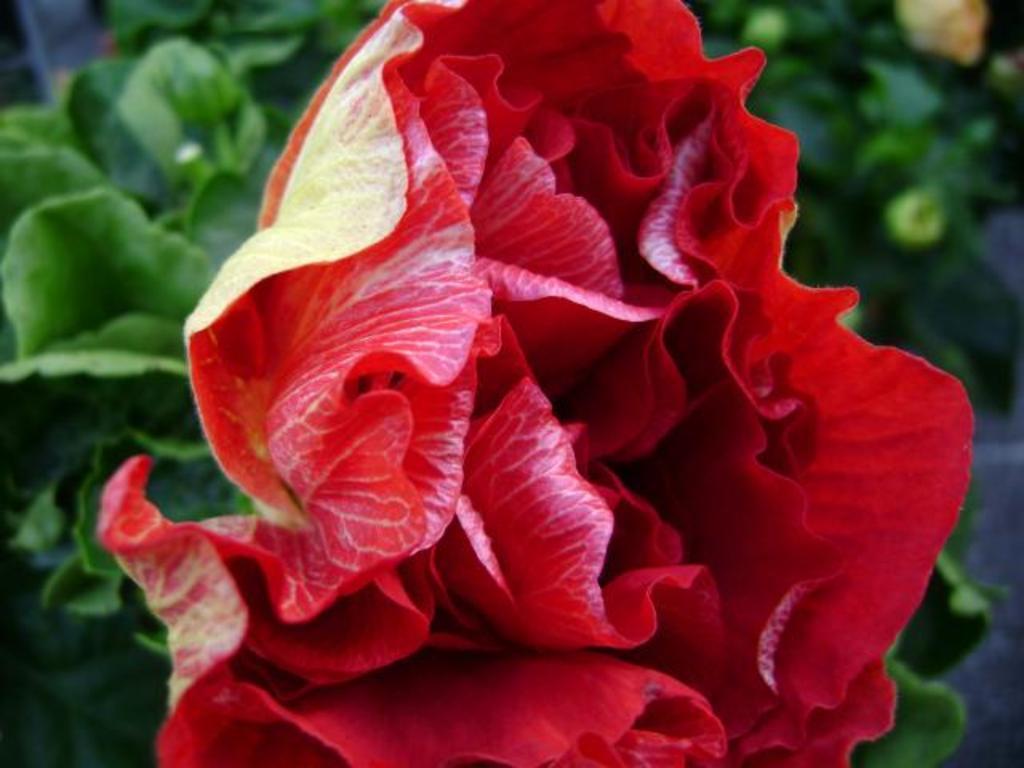Describe this image in one or two sentences. In this image there is a red flower. In the background there are plants. 